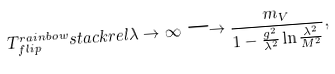Convert formula to latex. <formula><loc_0><loc_0><loc_500><loc_500>T _ { f l i p } ^ { r a i n b o w } s t a c k r e l \lambda \rightarrow \infty \longrightarrow \frac { m _ { V } } { 1 - \frac { g ^ { 2 } } { \lambda ^ { 2 } } \ln \frac { \lambda ^ { 2 } } { M ^ { 2 } } } ,</formula> 